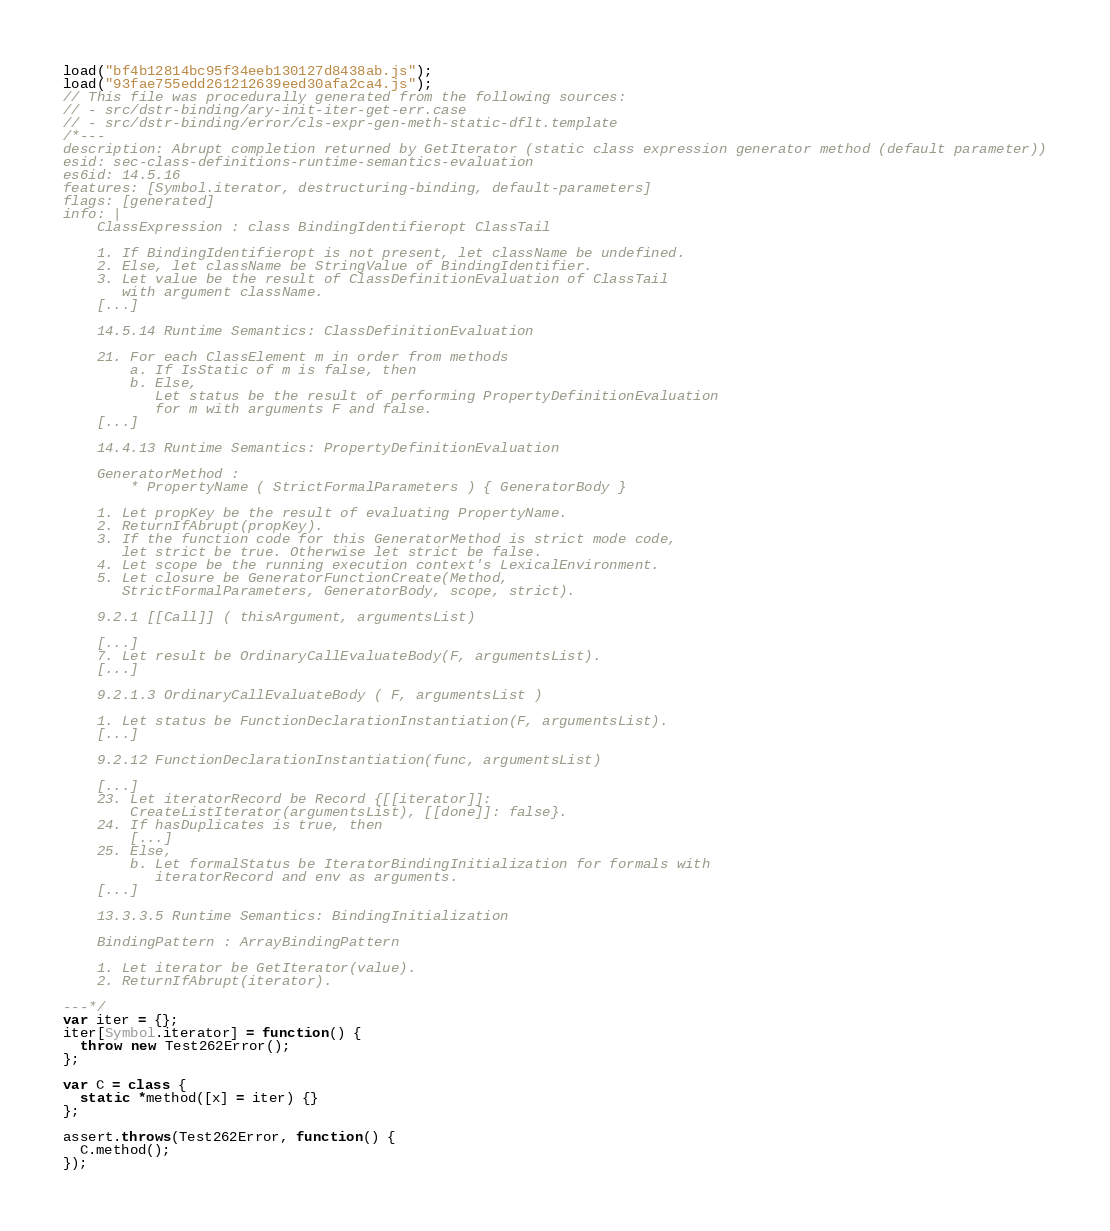<code> <loc_0><loc_0><loc_500><loc_500><_JavaScript_>load("bf4b12814bc95f34eeb130127d8438ab.js");
load("93fae755edd261212639eed30afa2ca4.js");
// This file was procedurally generated from the following sources:
// - src/dstr-binding/ary-init-iter-get-err.case
// - src/dstr-binding/error/cls-expr-gen-meth-static-dflt.template
/*---
description: Abrupt completion returned by GetIterator (static class expression generator method (default parameter))
esid: sec-class-definitions-runtime-semantics-evaluation
es6id: 14.5.16
features: [Symbol.iterator, destructuring-binding, default-parameters]
flags: [generated]
info: |
    ClassExpression : class BindingIdentifieropt ClassTail

    1. If BindingIdentifieropt is not present, let className be undefined.
    2. Else, let className be StringValue of BindingIdentifier.
    3. Let value be the result of ClassDefinitionEvaluation of ClassTail
       with argument className.
    [...]

    14.5.14 Runtime Semantics: ClassDefinitionEvaluation

    21. For each ClassElement m in order from methods
        a. If IsStatic of m is false, then
        b. Else,
           Let status be the result of performing PropertyDefinitionEvaluation
           for m with arguments F and false.
    [...]

    14.4.13 Runtime Semantics: PropertyDefinitionEvaluation

    GeneratorMethod :
        * PropertyName ( StrictFormalParameters ) { GeneratorBody }

    1. Let propKey be the result of evaluating PropertyName.
    2. ReturnIfAbrupt(propKey).
    3. If the function code for this GeneratorMethod is strict mode code,
       let strict be true. Otherwise let strict be false.
    4. Let scope be the running execution context's LexicalEnvironment.
    5. Let closure be GeneratorFunctionCreate(Method,
       StrictFormalParameters, GeneratorBody, scope, strict).

    9.2.1 [[Call]] ( thisArgument, argumentsList)

    [...]
    7. Let result be OrdinaryCallEvaluateBody(F, argumentsList).
    [...]

    9.2.1.3 OrdinaryCallEvaluateBody ( F, argumentsList )

    1. Let status be FunctionDeclarationInstantiation(F, argumentsList).
    [...]

    9.2.12 FunctionDeclarationInstantiation(func, argumentsList)

    [...]
    23. Let iteratorRecord be Record {[[iterator]]:
        CreateListIterator(argumentsList), [[done]]: false}.
    24. If hasDuplicates is true, then
        [...]
    25. Else,
        b. Let formalStatus be IteratorBindingInitialization for formals with
           iteratorRecord and env as arguments.
    [...]

    13.3.3.5 Runtime Semantics: BindingInitialization

    BindingPattern : ArrayBindingPattern

    1. Let iterator be GetIterator(value).
    2. ReturnIfAbrupt(iterator).

---*/
var iter = {};
iter[Symbol.iterator] = function() {
  throw new Test262Error();
};

var C = class {
  static *method([x] = iter) {}
};

assert.throws(Test262Error, function() {
  C.method();
});
</code> 